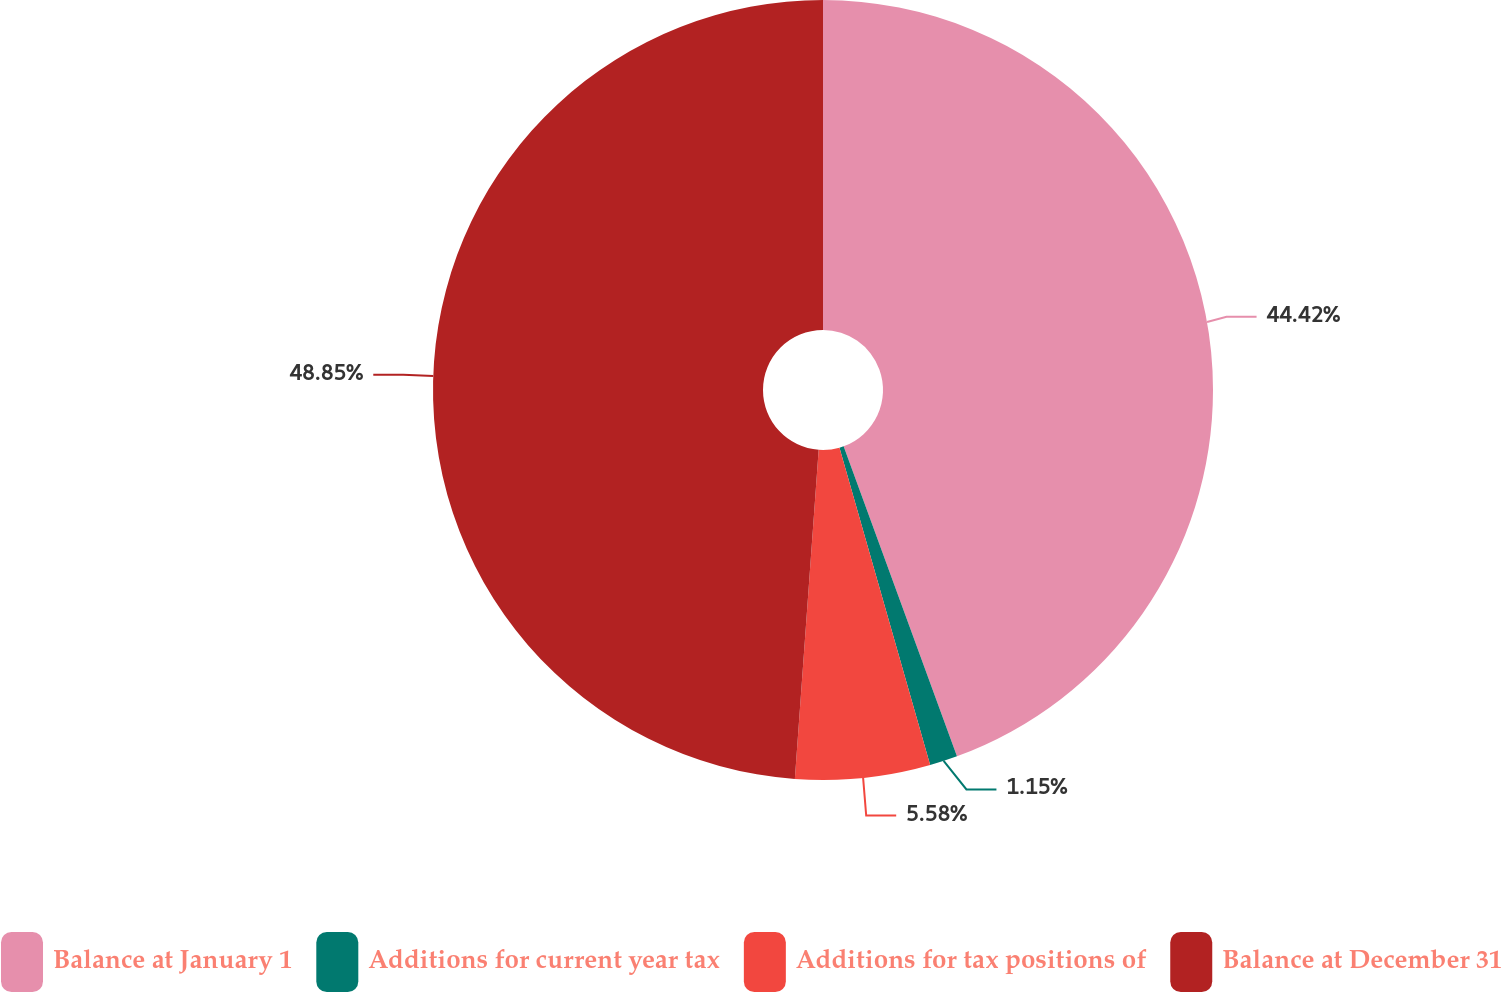<chart> <loc_0><loc_0><loc_500><loc_500><pie_chart><fcel>Balance at January 1<fcel>Additions for current year tax<fcel>Additions for tax positions of<fcel>Balance at December 31<nl><fcel>44.42%<fcel>1.15%<fcel>5.58%<fcel>48.85%<nl></chart> 